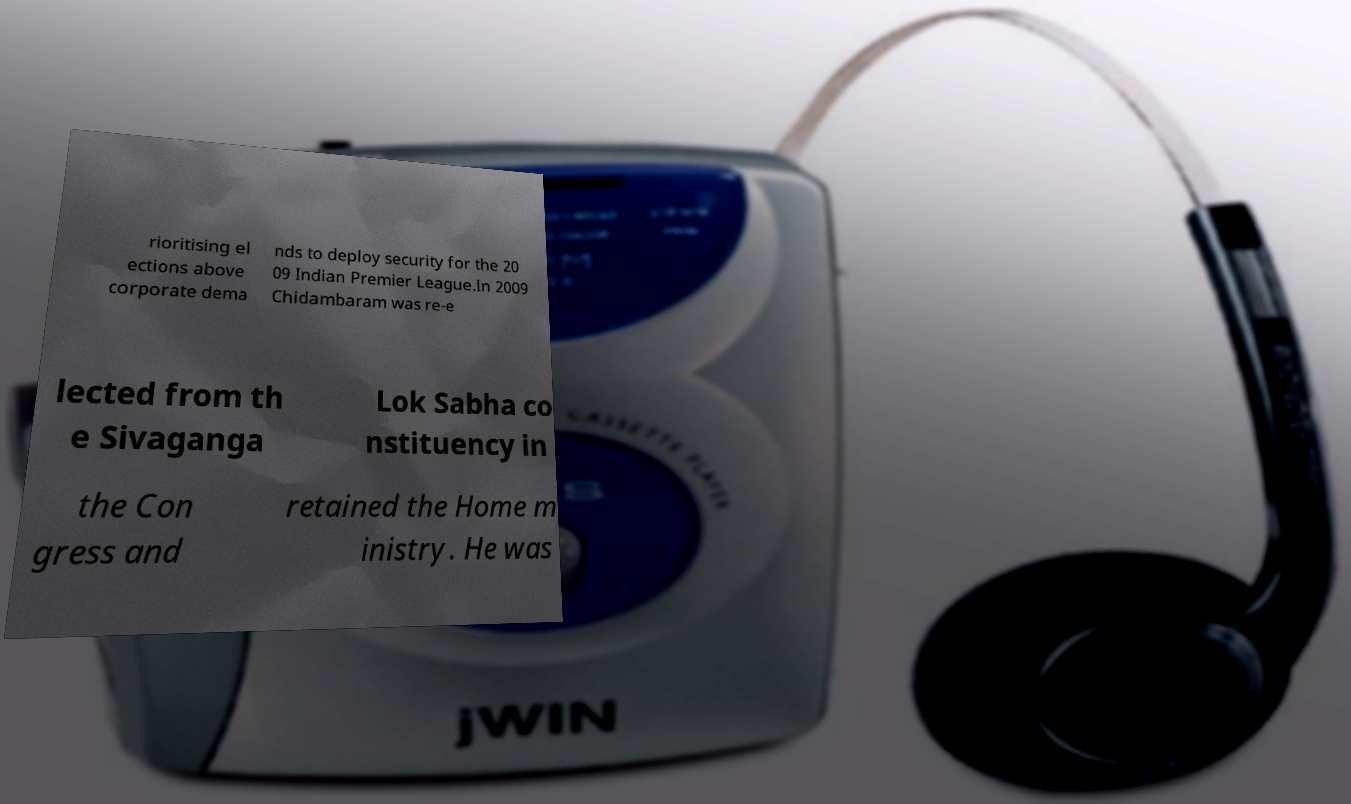Can you read and provide the text displayed in the image?This photo seems to have some interesting text. Can you extract and type it out for me? rioritising el ections above corporate dema nds to deploy security for the 20 09 Indian Premier League.In 2009 Chidambaram was re-e lected from th e Sivaganga Lok Sabha co nstituency in the Con gress and retained the Home m inistry. He was 